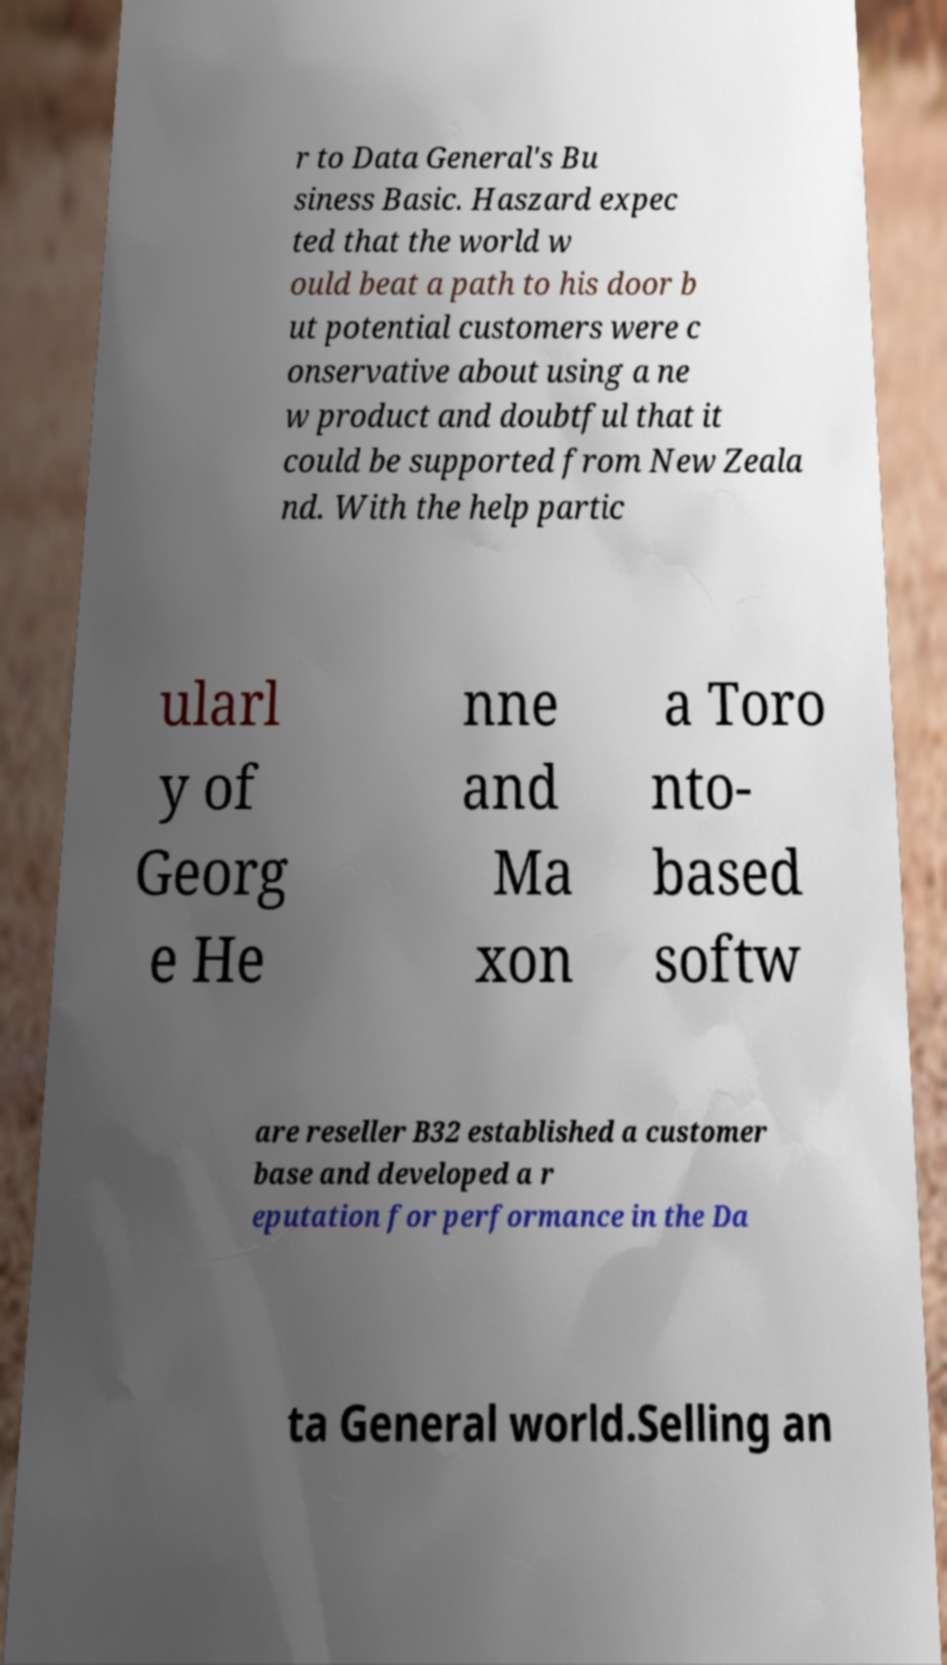Could you assist in decoding the text presented in this image and type it out clearly? r to Data General's Bu siness Basic. Haszard expec ted that the world w ould beat a path to his door b ut potential customers were c onservative about using a ne w product and doubtful that it could be supported from New Zeala nd. With the help partic ularl y of Georg e He nne and Ma xon a Toro nto- based softw are reseller B32 established a customer base and developed a r eputation for performance in the Da ta General world.Selling an 